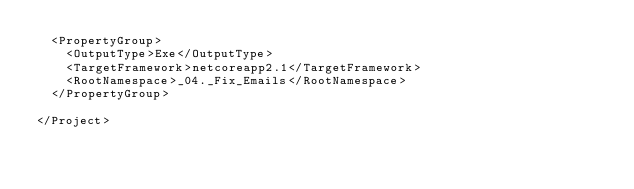<code> <loc_0><loc_0><loc_500><loc_500><_XML_>  <PropertyGroup>
    <OutputType>Exe</OutputType>
    <TargetFramework>netcoreapp2.1</TargetFramework>
    <RootNamespace>_04._Fix_Emails</RootNamespace>
  </PropertyGroup>

</Project>
</code> 